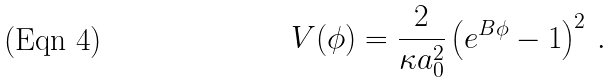Convert formula to latex. <formula><loc_0><loc_0><loc_500><loc_500>V ( \phi ) = \frac { 2 } { \kappa a _ { 0 } ^ { 2 } } \left ( e ^ { B \phi } - 1 \right ) ^ { 2 } \, .</formula> 